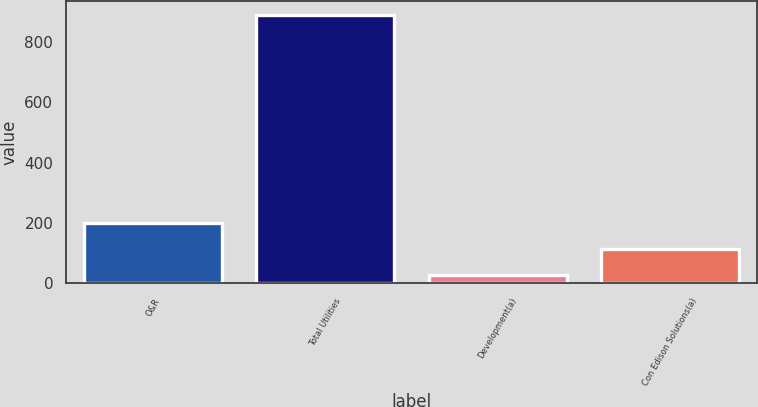<chart> <loc_0><loc_0><loc_500><loc_500><bar_chart><fcel>O&R<fcel>Total Utilities<fcel>Development(a)<fcel>Con Edison Solutions(a)<nl><fcel>201.2<fcel>890<fcel>29<fcel>115.1<nl></chart> 